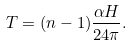Convert formula to latex. <formula><loc_0><loc_0><loc_500><loc_500>T = ( n - 1 ) \frac { \alpha H } { 2 4 \pi } .</formula> 